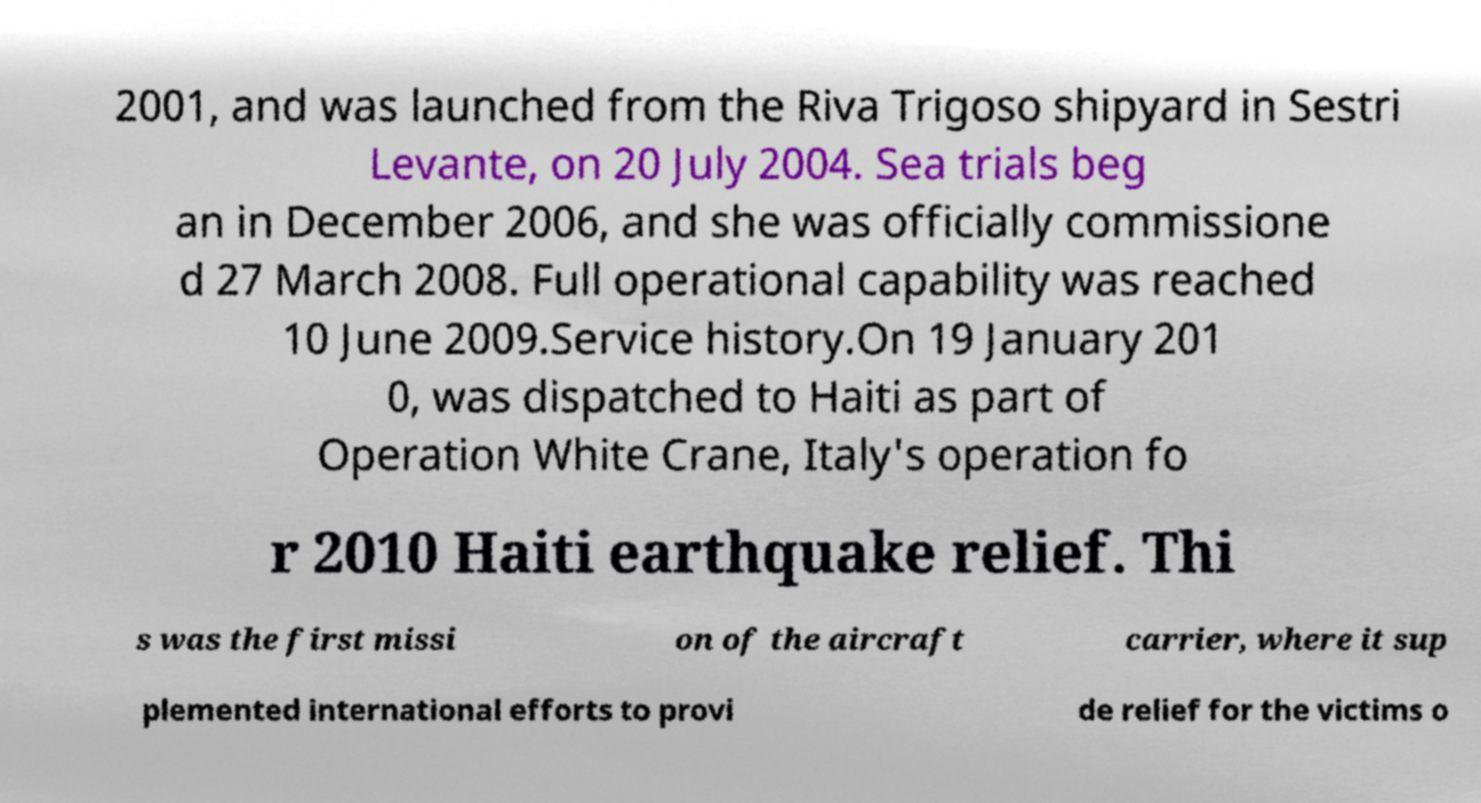There's text embedded in this image that I need extracted. Can you transcribe it verbatim? 2001, and was launched from the Riva Trigoso shipyard in Sestri Levante, on 20 July 2004. Sea trials beg an in December 2006, and she was officially commissione d 27 March 2008. Full operational capability was reached 10 June 2009.Service history.On 19 January 201 0, was dispatched to Haiti as part of Operation White Crane, Italy's operation fo r 2010 Haiti earthquake relief. Thi s was the first missi on of the aircraft carrier, where it sup plemented international efforts to provi de relief for the victims o 